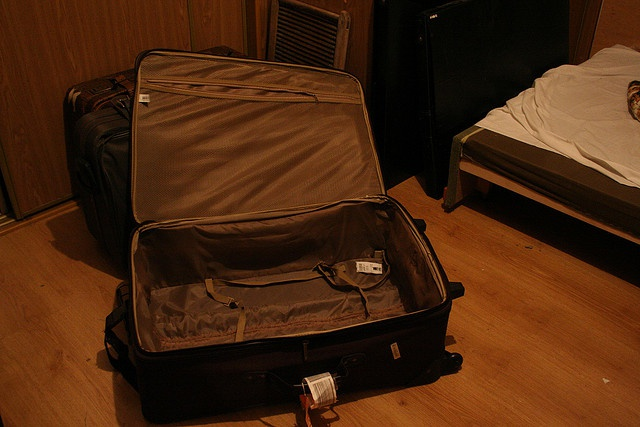Describe the objects in this image and their specific colors. I can see suitcase in maroon, black, and brown tones and suitcase in maroon, black, and brown tones in this image. 